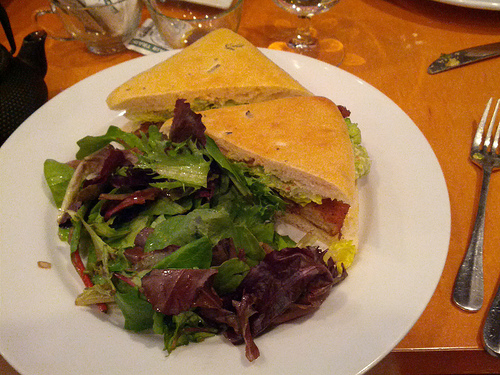Which color is the bread? The bread in the image has a light brown crust with a softer, lightly golden center, typical of many sandwich breads. 